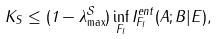Convert formula to latex. <formula><loc_0><loc_0><loc_500><loc_500>K _ { S } \leq ( 1 - \lambda _ { \max } ^ { \mathcal { S } } ) \inf _ { F _ { l } } I _ { F _ { l } } ^ { e n t } ( A ; B | E ) ,</formula> 